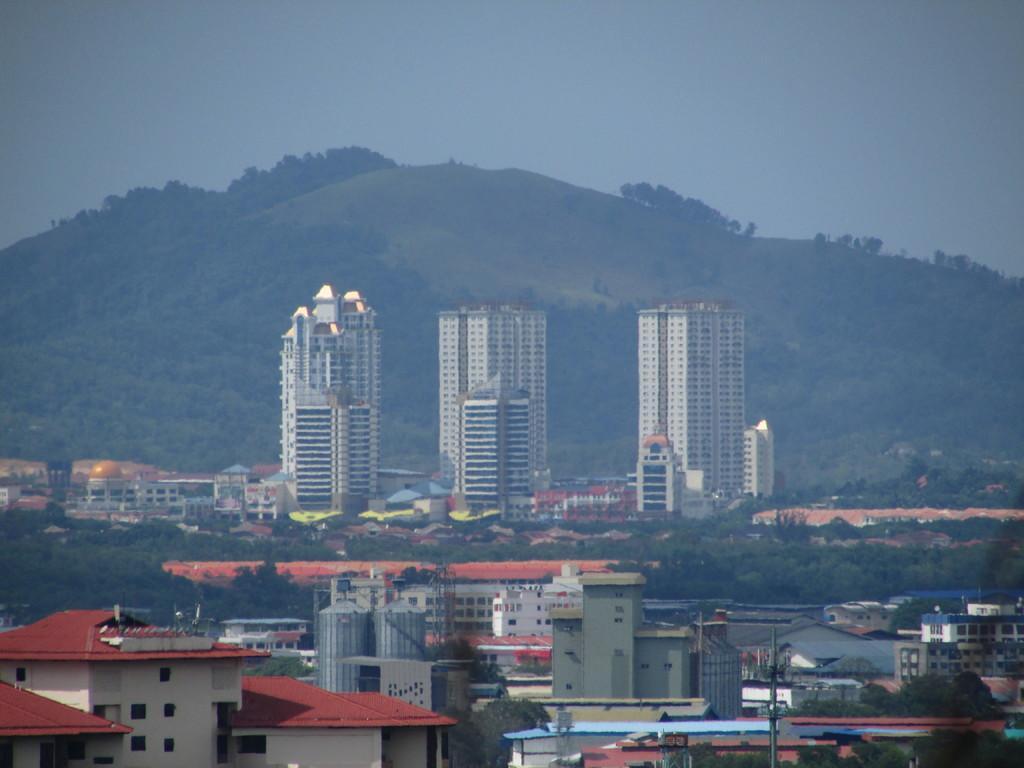In one or two sentences, can you explain what this image depicts? In this picture I can see houses, buildings, trees, there is a hill, and in the background there is sky. 